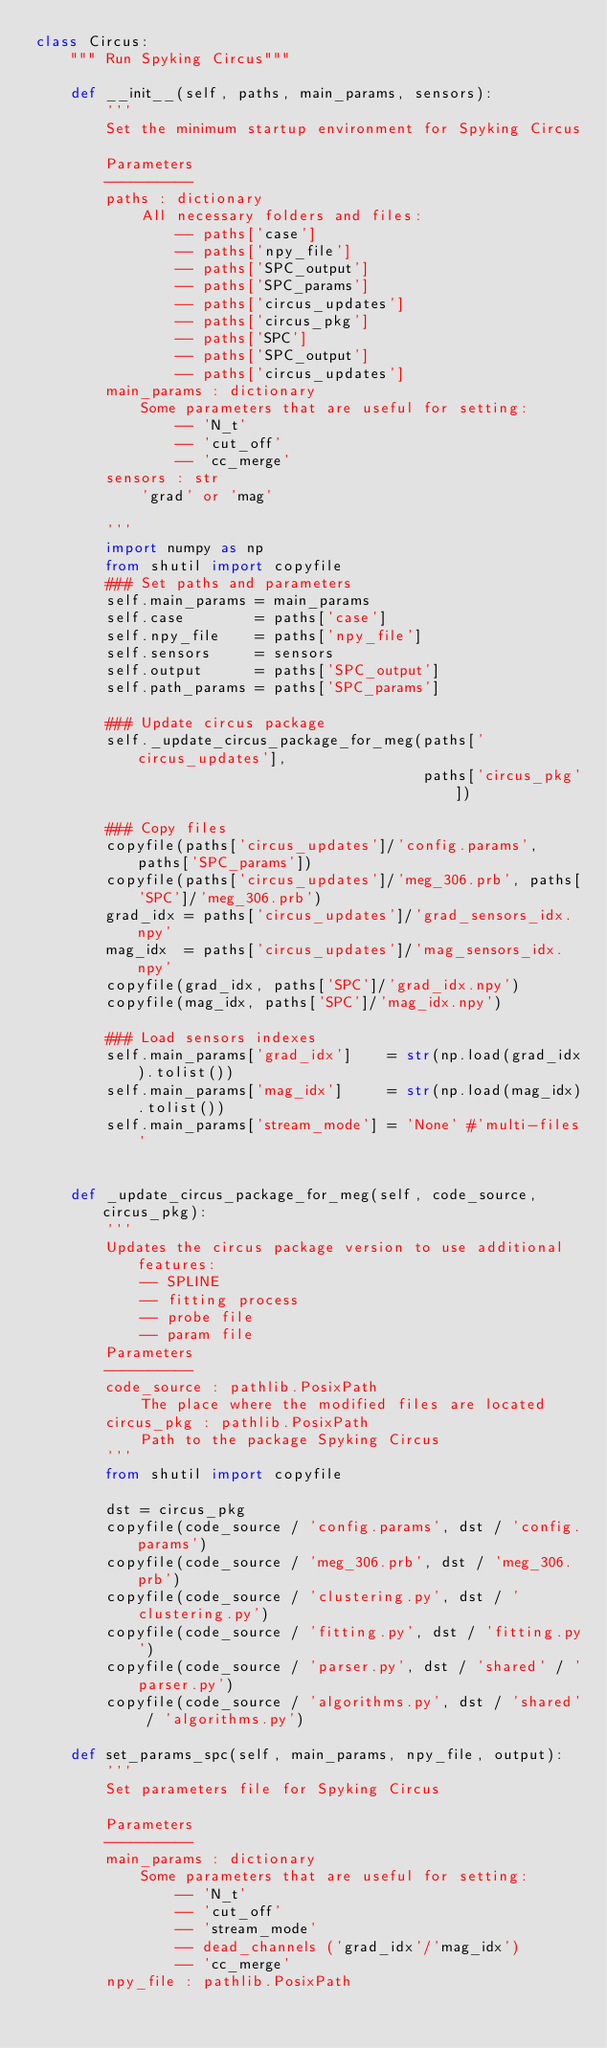Convert code to text. <code><loc_0><loc_0><loc_500><loc_500><_Python_>class Circus:
    """ Run Spyking Circus"""

    def __init__(self, paths, main_params, sensors):
        '''
        Set the minimum startup environment for Spyking Circus

        Parameters
        ----------
        paths : dictionary
            All necessary folders and files:
                -- paths['case']
                -- paths['npy_file']
                -- paths['SPC_output']
                -- paths['SPC_params']
                -- paths['circus_updates']
                -- paths['circus_pkg']
                -- paths['SPC']
                -- paths['SPC_output']
                -- paths['circus_updates']
        main_params : dictionary
            Some parameters that are useful for setting:
                -- 'N_t'
                -- 'cut_off'
                -- 'cc_merge'
        sensors : str
            'grad' or 'mag'

        '''
        import numpy as np
        from shutil import copyfile
        ### Set paths and parameters
        self.main_params = main_params        
        self.case        = paths['case']
        self.npy_file    = paths['npy_file']
        self.sensors     = sensors
        self.output      = paths['SPC_output']
        self.path_params = paths['SPC_params']
        
        ### Update circus package
        self._update_circus_package_for_meg(paths['circus_updates'], 
                                            paths['circus_pkg'])
                
        ### Copy files
        copyfile(paths['circus_updates']/'config.params', paths['SPC_params'])
        copyfile(paths['circus_updates']/'meg_306.prb', paths['SPC']/'meg_306.prb')
        grad_idx = paths['circus_updates']/'grad_sensors_idx.npy'
        mag_idx  = paths['circus_updates']/'mag_sensors_idx.npy'
        copyfile(grad_idx, paths['SPC']/'grad_idx.npy')
        copyfile(mag_idx, paths['SPC']/'mag_idx.npy')
        
        ### Load sensors indexes
        self.main_params['grad_idx']    = str(np.load(grad_idx).tolist())
        self.main_params['mag_idx']     = str(np.load(mag_idx).tolist())
        self.main_params['stream_mode'] = 'None' #'multi-files'
        
 
    def _update_circus_package_for_meg(self, code_source, circus_pkg):
        '''
        Updates the circus package version to use additional features:
            -- SPLINE
            -- fitting process
            -- probe file
            -- param file
        Parameters
        ----------
        code_source : pathlib.PosixPath
            The place where the modified files are located
        circus_pkg : pathlib.PosixPath
            Path to the package Spyking Circus
        '''
        from shutil import copyfile
        
        dst = circus_pkg
        copyfile(code_source / 'config.params', dst / 'config.params')
        copyfile(code_source / 'meg_306.prb', dst / 'meg_306.prb')
        copyfile(code_source / 'clustering.py', dst / 'clustering.py')
        copyfile(code_source / 'fitting.py', dst / 'fitting.py')
        copyfile(code_source / 'parser.py', dst / 'shared' / 'parser.py')
        copyfile(code_source / 'algorithms.py', dst / 'shared' / 'algorithms.py')

    def set_params_spc(self, main_params, npy_file, output):
        '''
        Set parameters file for Spyking Circus

        Parameters
        ----------
        main_params : dictionary
            Some parameters that are useful for setting:
                -- 'N_t'
                -- 'cut_off'
                -- 'stream_mode'
                -- dead_channels ('grad_idx'/'mag_idx')
                -- 'cc_merge'
        npy_file : pathlib.PosixPath</code> 